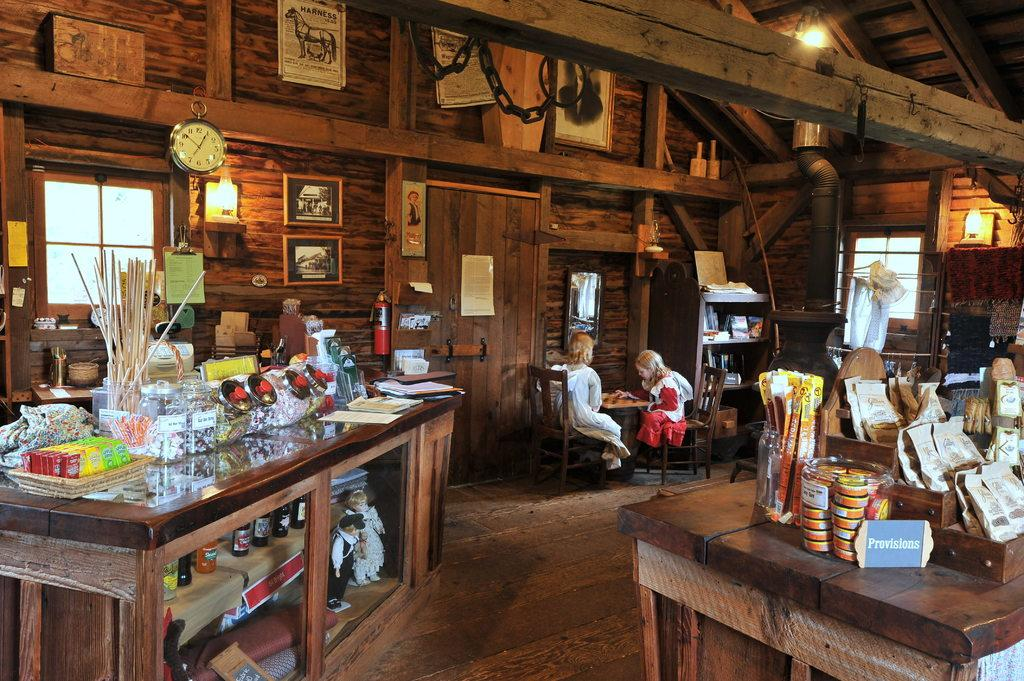How many girls are sitting in the image? There are two girls sitting on chairs in the image. What can be seen on the wall in the image? There is a clock visible in the image. What is on the tables in the image? There are posters on the tables in the image, as well as additional items or "stuffs." What type of worm can be seen crawling on the floor in the image? There is no worm present in the image; it only features two girls sitting on chairs, a clock on the wall, and posters and additional items on the tables. 